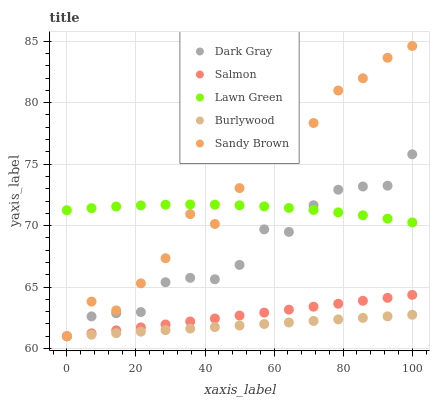Does Burlywood have the minimum area under the curve?
Answer yes or no. Yes. Does Sandy Brown have the maximum area under the curve?
Answer yes or no. Yes. Does Lawn Green have the minimum area under the curve?
Answer yes or no. No. Does Lawn Green have the maximum area under the curve?
Answer yes or no. No. Is Salmon the smoothest?
Answer yes or no. Yes. Is Sandy Brown the roughest?
Answer yes or no. Yes. Is Lawn Green the smoothest?
Answer yes or no. No. Is Lawn Green the roughest?
Answer yes or no. No. Does Dark Gray have the lowest value?
Answer yes or no. Yes. Does Lawn Green have the lowest value?
Answer yes or no. No. Does Sandy Brown have the highest value?
Answer yes or no. Yes. Does Lawn Green have the highest value?
Answer yes or no. No. Is Burlywood less than Lawn Green?
Answer yes or no. Yes. Is Lawn Green greater than Burlywood?
Answer yes or no. Yes. Does Salmon intersect Dark Gray?
Answer yes or no. Yes. Is Salmon less than Dark Gray?
Answer yes or no. No. Is Salmon greater than Dark Gray?
Answer yes or no. No. Does Burlywood intersect Lawn Green?
Answer yes or no. No. 